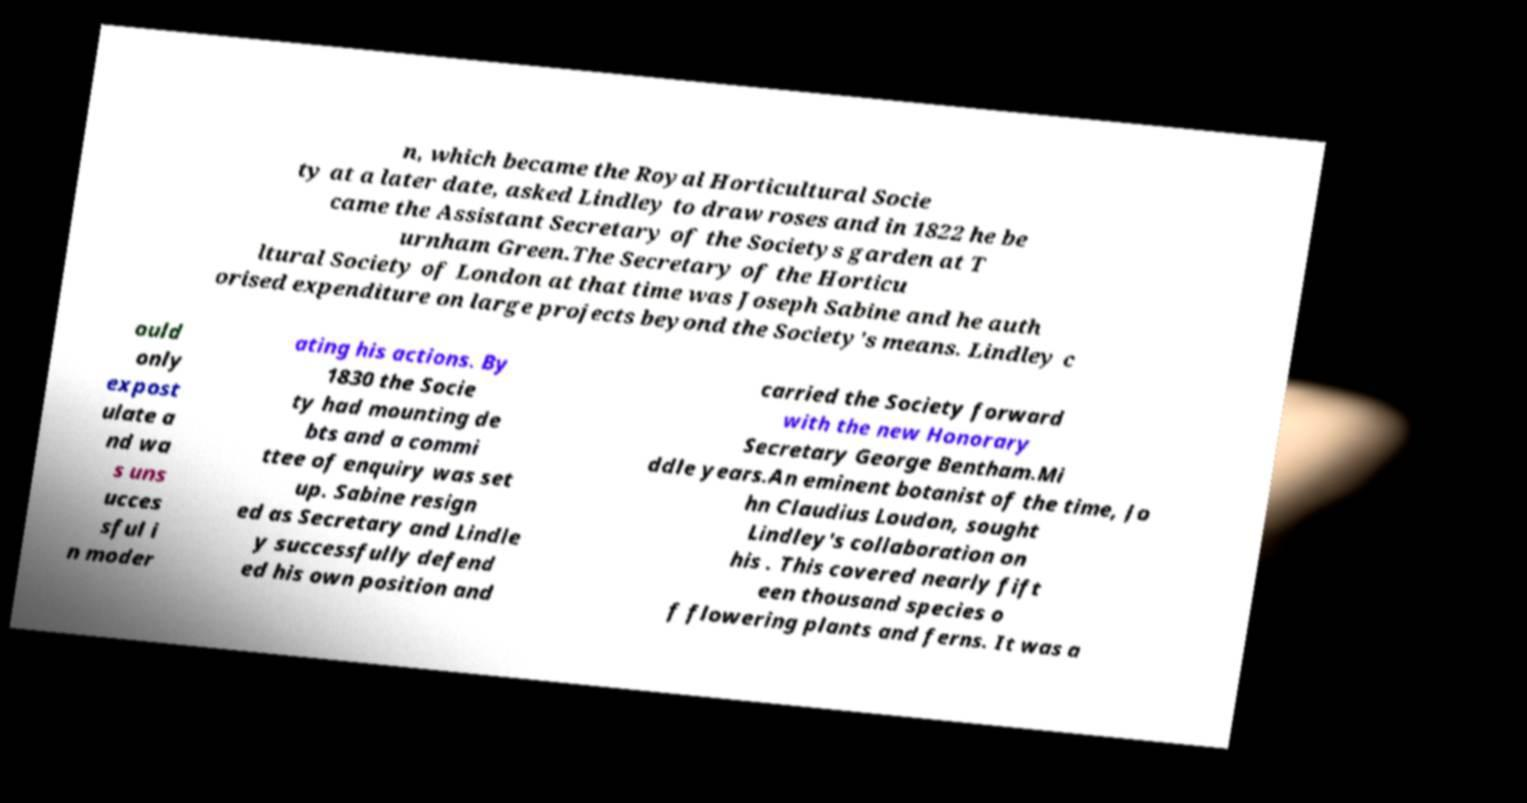Can you read and provide the text displayed in the image?This photo seems to have some interesting text. Can you extract and type it out for me? n, which became the Royal Horticultural Socie ty at a later date, asked Lindley to draw roses and in 1822 he be came the Assistant Secretary of the Societys garden at T urnham Green.The Secretary of the Horticu ltural Society of London at that time was Joseph Sabine and he auth orised expenditure on large projects beyond the Society's means. Lindley c ould only expost ulate a nd wa s uns ucces sful i n moder ating his actions. By 1830 the Socie ty had mounting de bts and a commi ttee of enquiry was set up. Sabine resign ed as Secretary and Lindle y successfully defend ed his own position and carried the Society forward with the new Honorary Secretary George Bentham.Mi ddle years.An eminent botanist of the time, Jo hn Claudius Loudon, sought Lindley's collaboration on his . This covered nearly fift een thousand species o f flowering plants and ferns. It was a 